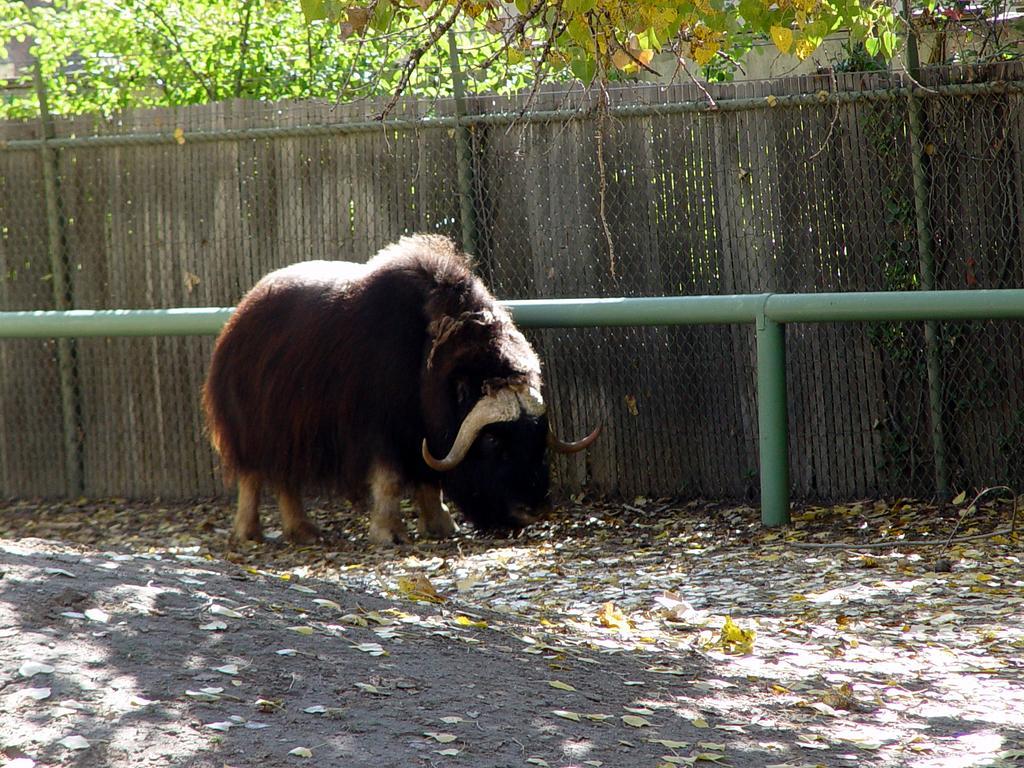Can you describe this image briefly? There is one muskox in the middle of this image and there is a fence in the background. We can see trees at the top of this image. 